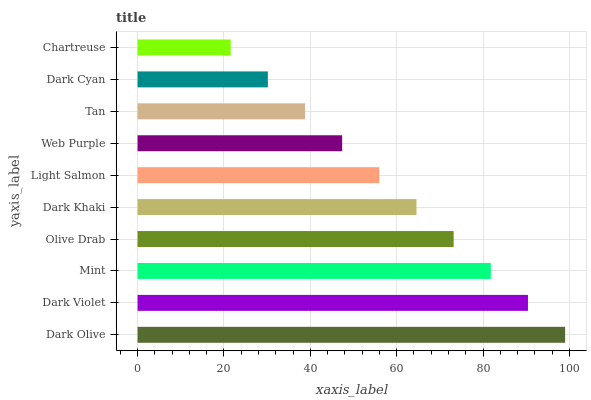Is Chartreuse the minimum?
Answer yes or no. Yes. Is Dark Olive the maximum?
Answer yes or no. Yes. Is Dark Violet the minimum?
Answer yes or no. No. Is Dark Violet the maximum?
Answer yes or no. No. Is Dark Olive greater than Dark Violet?
Answer yes or no. Yes. Is Dark Violet less than Dark Olive?
Answer yes or no. Yes. Is Dark Violet greater than Dark Olive?
Answer yes or no. No. Is Dark Olive less than Dark Violet?
Answer yes or no. No. Is Dark Khaki the high median?
Answer yes or no. Yes. Is Light Salmon the low median?
Answer yes or no. Yes. Is Chartreuse the high median?
Answer yes or no. No. Is Dark Violet the low median?
Answer yes or no. No. 